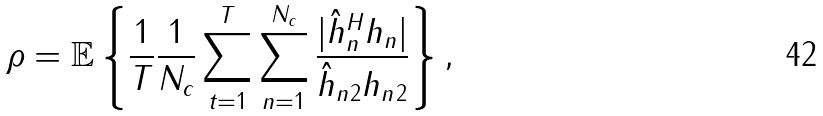Convert formula to latex. <formula><loc_0><loc_0><loc_500><loc_500>\rho = \mathbb { E } \left \{ \frac { 1 } { T } \frac { 1 } { N _ { c } } \sum _ { t = 1 } ^ { T } \sum _ { n = 1 } ^ { N _ { c } } \frac { | \hat { h } _ { n } ^ { H } { h } _ { n } | } { \| \hat { h } _ { n } \| _ { 2 } \| { h } _ { n } \| _ { 2 } } \right \} ,</formula> 